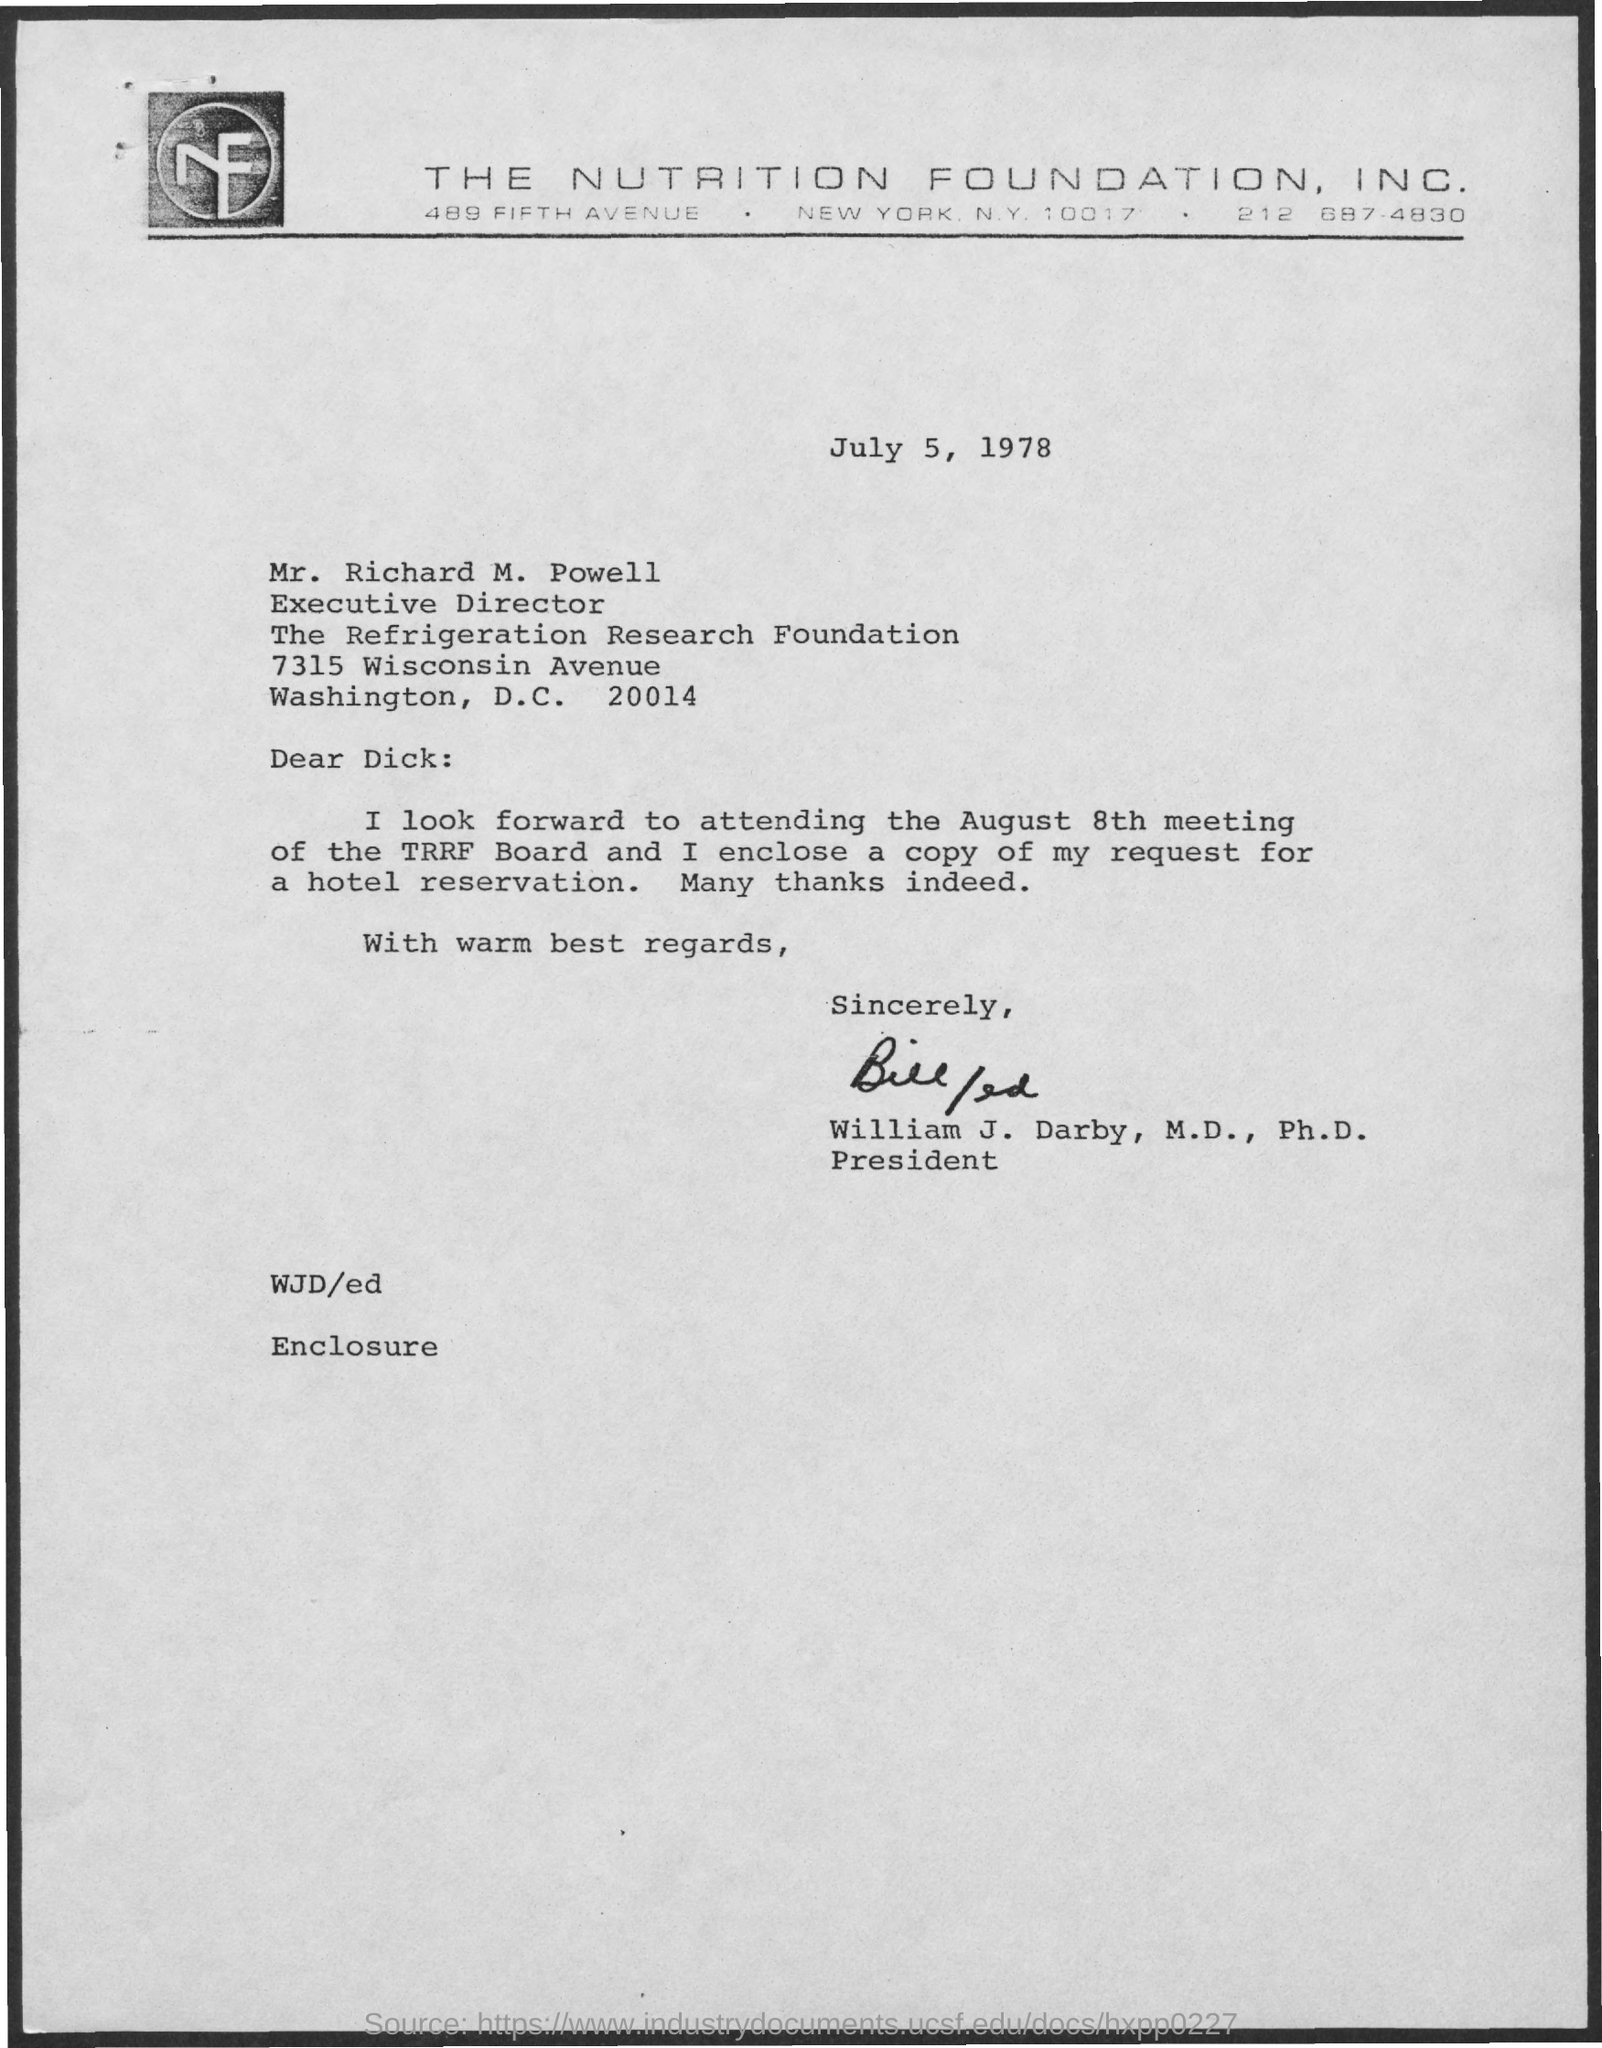Highlight a few significant elements in this photo. The letter is from William J. Darby, M.D., Ph.D. The meeting of the TRRF Board will take place on August 8th. The document is dated July 5, 1978. 